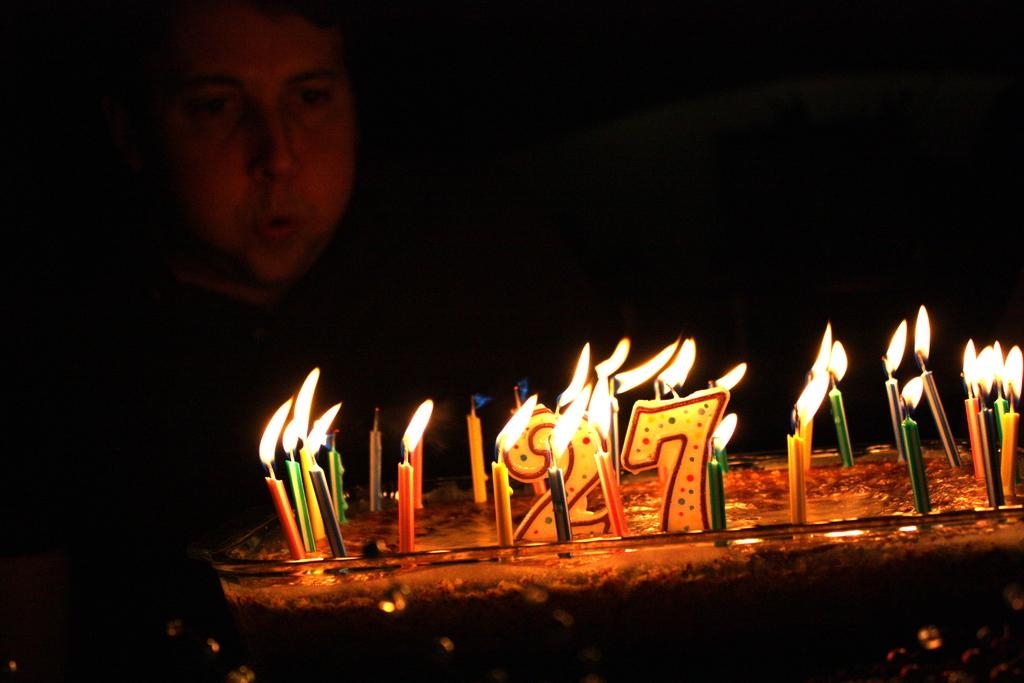What is the main subject of the image? There is a cake in the image. How many candles are on the cake? There are many candles on the cake. Can you describe the background of the image? The background of the image is dark. Is there anyone else visible in the image besides the cake? Yes, there is a man in the background of the image. What type of library is depicted in the image? There is no library present in the image; it features a cake with many candles and a man in the background. What territory is being claimed by the destruction in the image? There is no destruction present in the image, and therefore no territory is being claimed. 